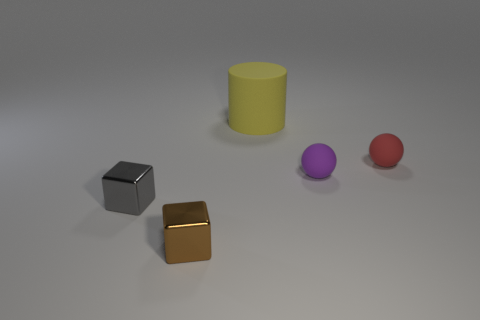Subtract 1 balls. How many balls are left? 1 Subtract all purple spheres. How many spheres are left? 1 Subtract all green cubes. Subtract all gray cylinders. How many cubes are left? 2 Subtract all blue spheres. How many red cylinders are left? 0 Add 5 purple rubber things. How many objects exist? 10 Subtract 0 blue spheres. How many objects are left? 5 Subtract all cubes. How many objects are left? 3 Subtract all large yellow objects. Subtract all gray metal things. How many objects are left? 3 Add 2 brown objects. How many brown objects are left? 3 Add 1 brown shiny balls. How many brown shiny balls exist? 1 